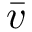Convert formula to latex. <formula><loc_0><loc_0><loc_500><loc_500>\bar { v }</formula> 